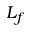<formula> <loc_0><loc_0><loc_500><loc_500>L _ { f }</formula> 